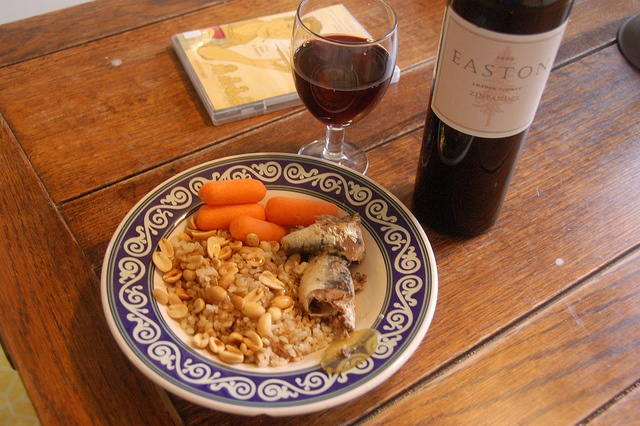Describe the objects in this image and their specific colors. I can see dining table in brown, gray, maroon, tan, and black tones, bowl in darkgray, tan, brown, red, and maroon tones, bottle in darkgray, black, gray, and tan tones, wine glass in darkgray, maroon, black, gray, and tan tones, and book in darkgray, tan, and gray tones in this image. 